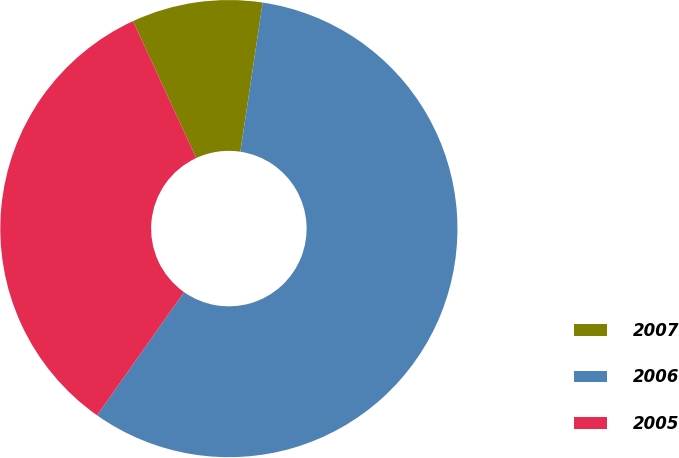<chart> <loc_0><loc_0><loc_500><loc_500><pie_chart><fcel>2007<fcel>2006<fcel>2005<nl><fcel>9.25%<fcel>57.42%<fcel>33.33%<nl></chart> 